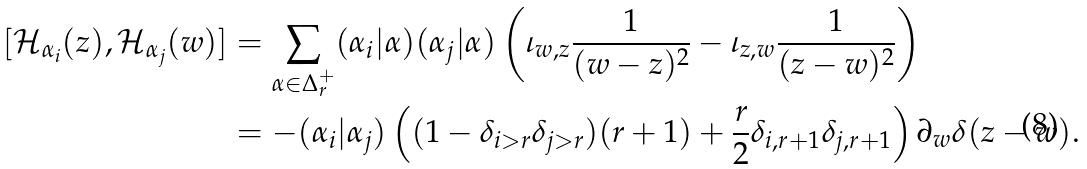Convert formula to latex. <formula><loc_0><loc_0><loc_500><loc_500>[ \mathcal { H } _ { \alpha _ { i } } ( z ) , \mathcal { H } _ { \alpha _ { j } } ( w ) ] & = \sum _ { \alpha \in \Delta ^ { + } _ { r } } ( \alpha _ { i } | \alpha ) ( \alpha _ { j } | \alpha ) \left ( \iota _ { w , z } { \frac { 1 } { ( w - z ) ^ { 2 } } } - \iota _ { z , w } { \frac { 1 } { ( z - w ) ^ { 2 } } } \right ) \\ & = - ( \alpha _ { i } | \alpha _ { j } ) \left ( ( 1 - \delta _ { i > r } \delta _ { j > r } ) ( r + 1 ) + \frac { r } { 2 } \delta _ { i , r + 1 } \delta _ { j , r + 1 } \right ) \partial _ { w } \delta ( z - w ) .</formula> 